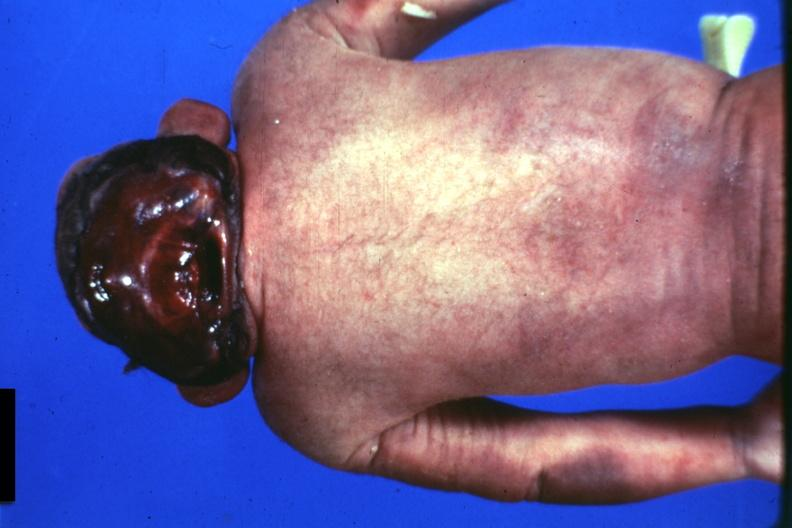s anencephaly present?
Answer the question using a single word or phrase. Yes 